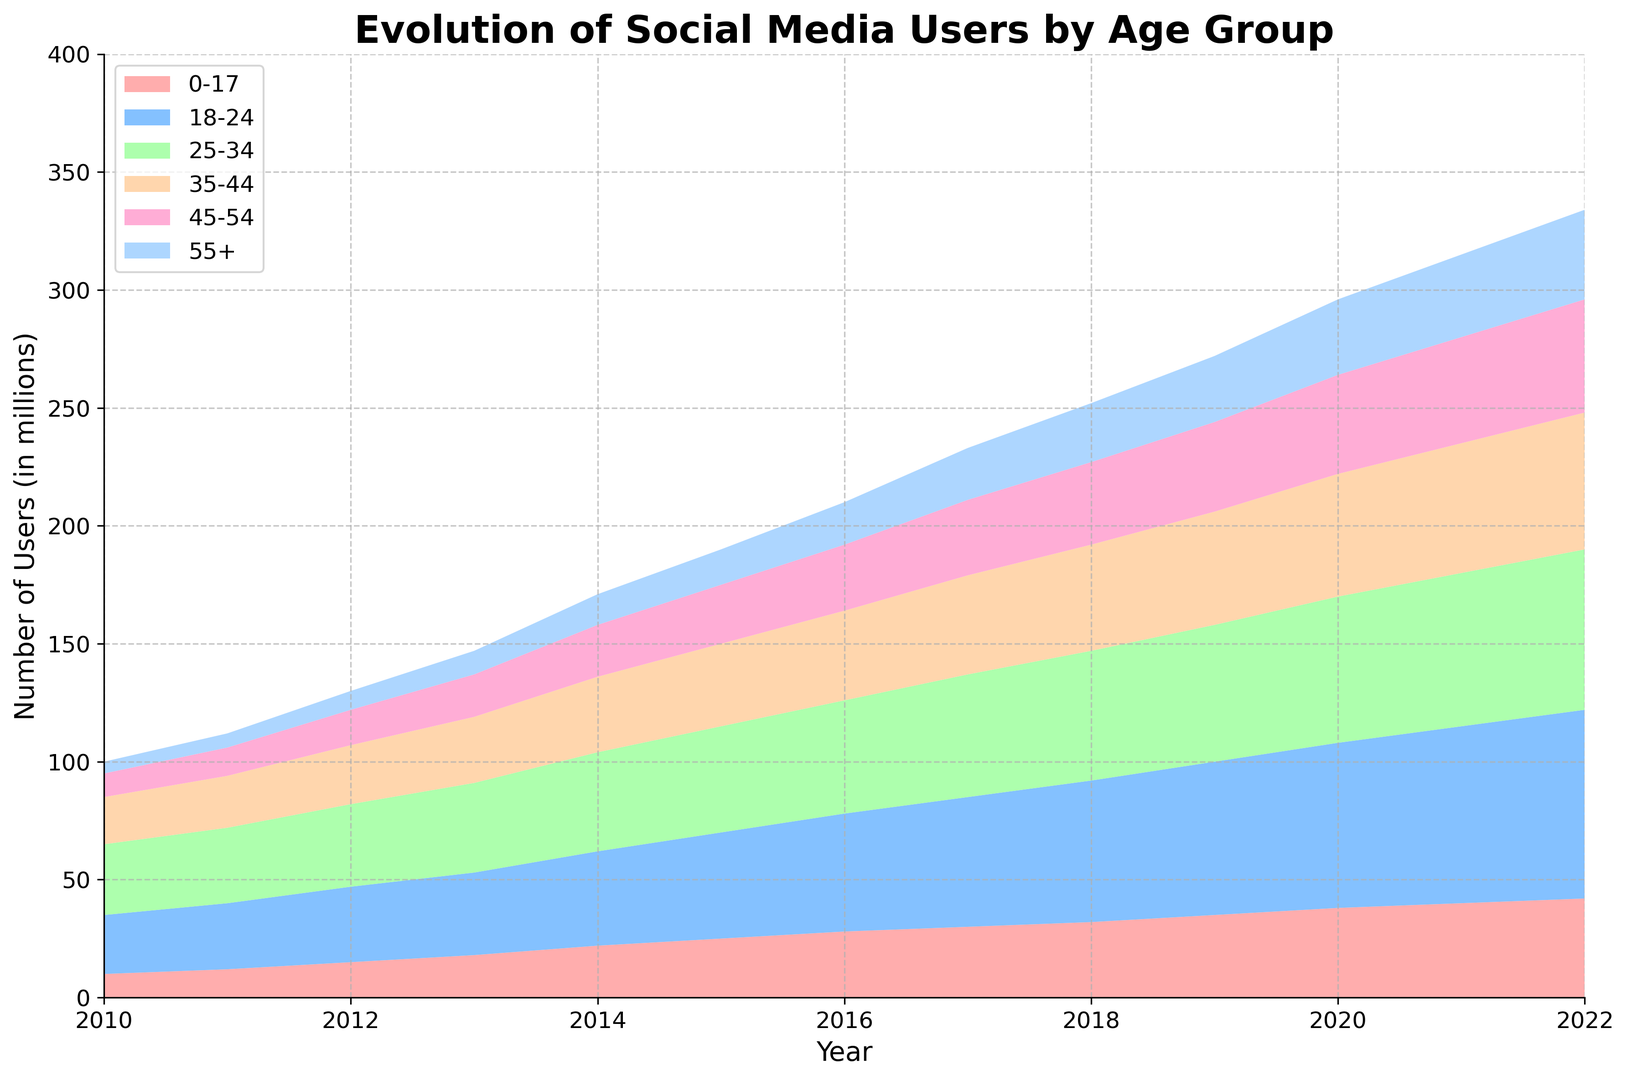What is the total number of social media users for all age groups in 2022? To find the total number of social media users for all age groups in 2022, sum up the values of each age group for the year 2022: 42 + 80 + 68 + 58 + 48 + 38 = 334
Answer: 334 Which age group saw the largest increase in users from 2010 to 2022? Calculate the difference in the number of users for each age group between 2010 and 2022. The increases are: (42-10) = 32, (80-25) = 55, (68-30) = 38, (58-20) = 38, (48-10) = 38, (38-5) = 33. The age group 18-24 has the largest increase with 55
Answer: 18-24 In which year did the 18-24 age group surpass 50 million users? From the data, identify the year when the 18-24 age group had more than 50 million users for the first time. The year is 2016 when the value reaches 50.
Answer: 2016 Compare the growth rate of the 0-17 age group to the 55+ age group from 2010 to 2022. Which grew faster? Calculate the growth rate for both age groups. The 0-17 group grew from 10 to 42, and the 55+ group grew from 5 to 38. For 0-17: (42-10)/10 = 3.2 times; for 55+: (38-5)/5 = 6.6 times. Therefore, the 55+ group grew faster.
Answer: 55+ What is the average number of social media users in millions for the 25-34 age group from 2018 to 2022? First, extract the values from 2018 to 2022 for the 25-34 age group: 55, 58, 62, 65, 68. Sum them up: 55 + 58 + 62 + 65 + 68 = 308. Then divide by the number of years: 308 / 5 = 61.6
Answer: 61.6 